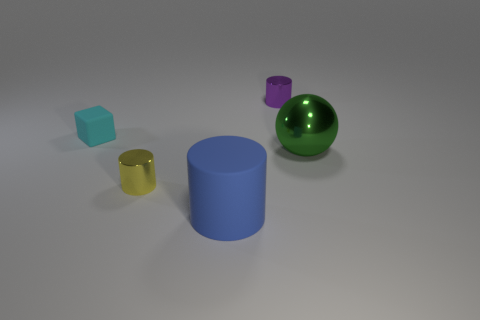Subtract all yellow cylinders. How many cylinders are left? 2 Subtract 1 blocks. How many blocks are left? 0 Add 2 large brown objects. How many objects exist? 7 Subtract all gray cylinders. How many purple cubes are left? 0 Add 4 large cyan matte cubes. How many large cyan matte cubes exist? 4 Subtract all purple cylinders. How many cylinders are left? 2 Subtract 0 red spheres. How many objects are left? 5 Subtract all cylinders. How many objects are left? 2 Subtract all red balls. Subtract all red cubes. How many balls are left? 1 Subtract all big things. Subtract all large blue balls. How many objects are left? 3 